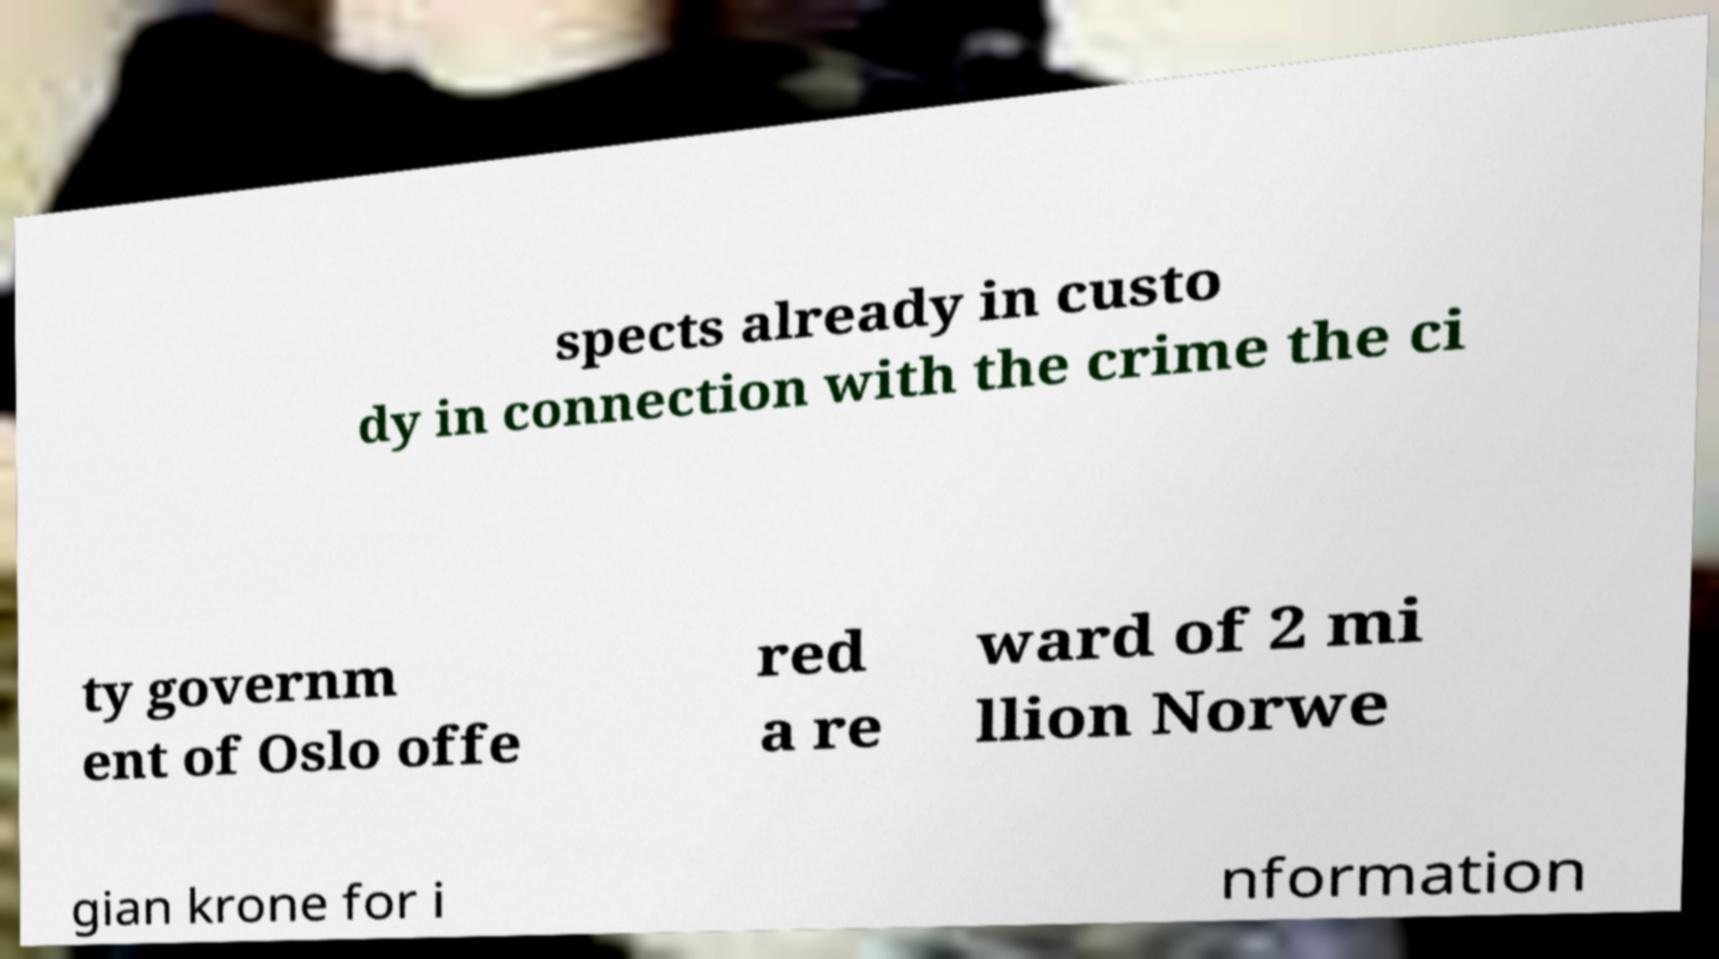Could you assist in decoding the text presented in this image and type it out clearly? spects already in custo dy in connection with the crime the ci ty governm ent of Oslo offe red a re ward of 2 mi llion Norwe gian krone for i nformation 